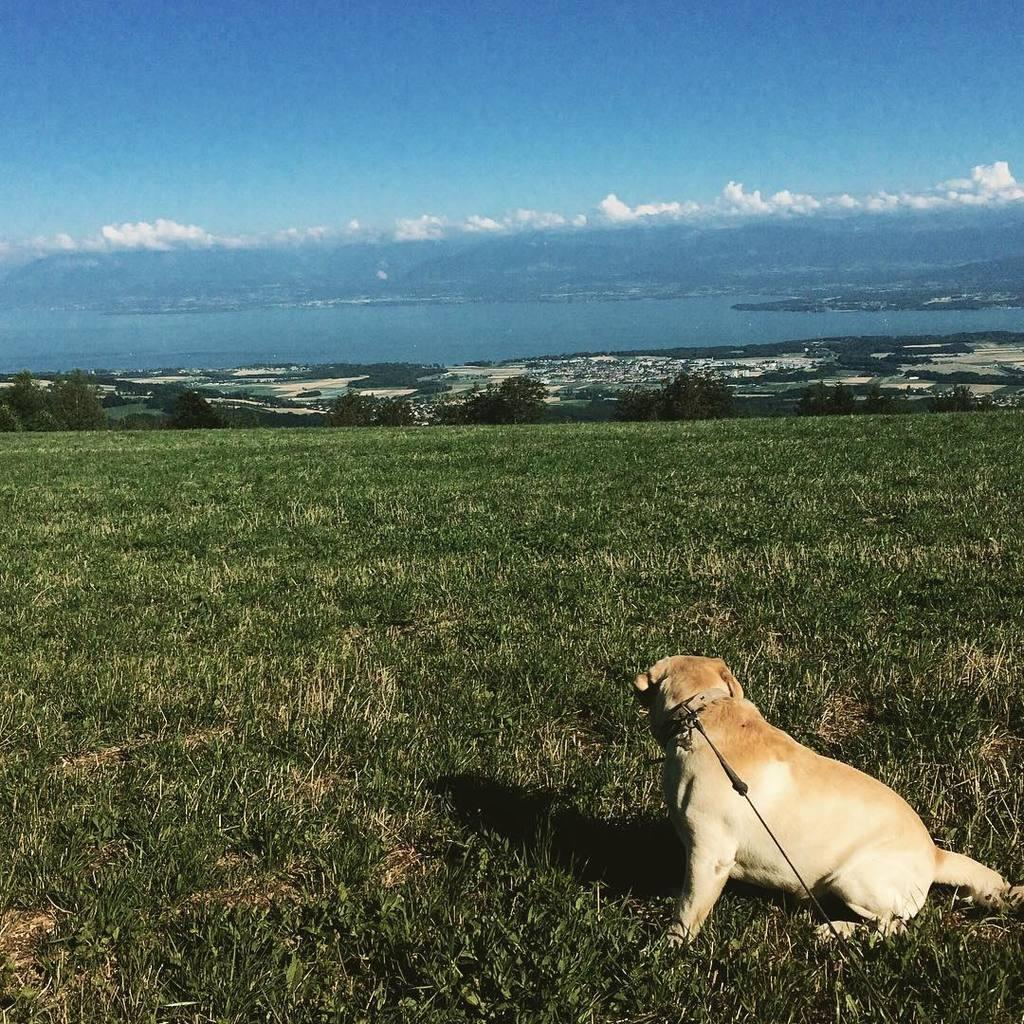What animal can be seen on the right side of the image? There is a dog on the right side of the image. What type of terrain is visible at the bottom of the image? There is grass at the bottom of the image. What can be seen in the background of the image? There are trees, hills, water, and the sky visible in the background of the image. What is the condition of the sky in the image? The sky is visible in the background of the image, and there are clouds present. What type of hook can be seen hanging from the tree in the image? There is no hook present in the image; it features a dog, grass, trees, hills, water, and the sky. What type of sail can be seen on the water in the image? There is no sail present in the image; it features a dog, grass, trees, hills, water, and the sky. 